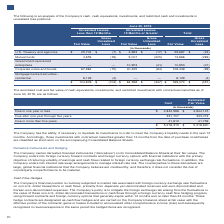According to Lam Research Corporation's financial document, What is the amount of fair value of cash equivalents, investments, and restricted investments with contractual maturities as of June 30, 2019 that is due in more than five years? According to the financial document, 41,612 (in thousands). The relevant text states: "Due in more than five years 41,612 41,756..." Also, What is the amount of amortized cost of cash equivalents, investments, and restricted investments with contractual maturities as of June 30, 2019 that is due in one year or less? According to the financial document, $4,842,996 (in thousands). The relevant text states: "Due in one year or less $ 4,842,996 $ 4,844,145..." Also, What is the amount of fair value of cash equivalents, investments, and restricted investments with contractual maturities as of June 30, 2019 that is due after one year through five years? According to the financial document, 333,019 (in thousands). The relevant text states: "Due after one year through five years 331,707 333,019..." Also, can you calculate: What is the percentage of fair value of cash equivalents, investments, and restricted investments with contractual maturities that is due in more than five years in the total fair value? Based on the calculation: 41,756/5,218,920, the result is 0.8 (percentage). This is based on the information: "Due in more than five years 41,612 41,756 $ 5,216,315 $ 5,218,920..." The key data points involved are: 41,756, 5,218,920. Also, can you calculate: What is the percentage of amortized cost of cash equivalents, investments, and restricted investments with contractual maturities that is due in more than five year in the total cost? Based on the calculation: 41,612/5,216,315, the result is 0.8 (percentage). This is based on the information: "Due in more than five years 41,612 41,756 $ 5,216,315 $ 5,218,920..." The key data points involved are: 41,612, 5,216,315. Additionally, Which measurement of cash equivalents, investments, and restricted investments with contractual maturities has a higher total amount? According to the financial document, Fair Value. The relevant text states: "The amortized cost and fair value of cash equivalents, investments, and restricted investments with contractual maturities as of June..." 